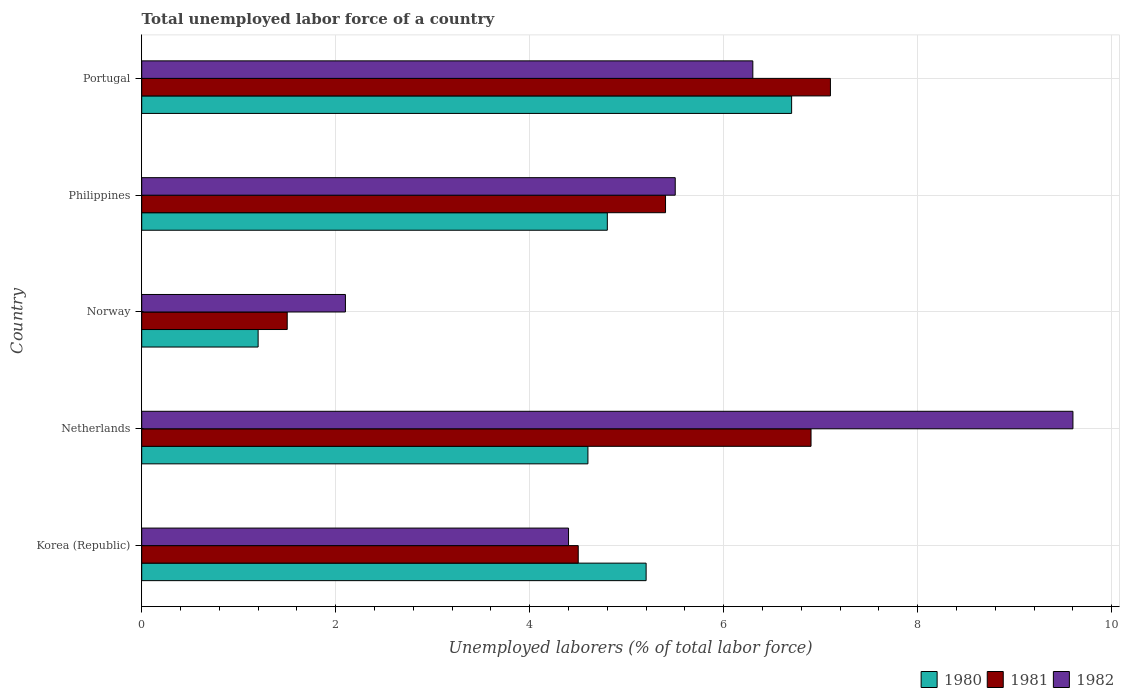How many different coloured bars are there?
Provide a succinct answer. 3. In how many cases, is the number of bars for a given country not equal to the number of legend labels?
Ensure brevity in your answer.  0. Across all countries, what is the maximum total unemployed labor force in 1980?
Offer a very short reply. 6.7. Across all countries, what is the minimum total unemployed labor force in 1981?
Your response must be concise. 1.5. In which country was the total unemployed labor force in 1981 minimum?
Your answer should be compact. Norway. What is the total total unemployed labor force in 1982 in the graph?
Offer a terse response. 27.9. What is the difference between the total unemployed labor force in 1980 in Norway and that in Philippines?
Your response must be concise. -3.6. What is the difference between the total unemployed labor force in 1982 in Norway and the total unemployed labor force in 1980 in Korea (Republic)?
Provide a succinct answer. -3.1. What is the average total unemployed labor force in 1981 per country?
Offer a terse response. 5.08. What is the difference between the total unemployed labor force in 1981 and total unemployed labor force in 1982 in Philippines?
Offer a very short reply. -0.1. What is the ratio of the total unemployed labor force in 1981 in Korea (Republic) to that in Netherlands?
Provide a succinct answer. 0.65. Is the total unemployed labor force in 1982 in Netherlands less than that in Norway?
Your answer should be very brief. No. What is the difference between the highest and the second highest total unemployed labor force in 1981?
Your response must be concise. 0.2. What is the difference between the highest and the lowest total unemployed labor force in 1982?
Ensure brevity in your answer.  7.5. In how many countries, is the total unemployed labor force in 1982 greater than the average total unemployed labor force in 1982 taken over all countries?
Provide a succinct answer. 2. Is it the case that in every country, the sum of the total unemployed labor force in 1980 and total unemployed labor force in 1981 is greater than the total unemployed labor force in 1982?
Make the answer very short. Yes. How many bars are there?
Your response must be concise. 15. Are the values on the major ticks of X-axis written in scientific E-notation?
Make the answer very short. No. Does the graph contain any zero values?
Provide a short and direct response. No. Does the graph contain grids?
Your answer should be very brief. Yes. How many legend labels are there?
Your response must be concise. 3. What is the title of the graph?
Your answer should be compact. Total unemployed labor force of a country. Does "2008" appear as one of the legend labels in the graph?
Your response must be concise. No. What is the label or title of the X-axis?
Your response must be concise. Unemployed laborers (% of total labor force). What is the Unemployed laborers (% of total labor force) in 1980 in Korea (Republic)?
Provide a short and direct response. 5.2. What is the Unemployed laborers (% of total labor force) in 1982 in Korea (Republic)?
Your answer should be compact. 4.4. What is the Unemployed laborers (% of total labor force) in 1980 in Netherlands?
Provide a succinct answer. 4.6. What is the Unemployed laborers (% of total labor force) in 1981 in Netherlands?
Offer a very short reply. 6.9. What is the Unemployed laborers (% of total labor force) in 1982 in Netherlands?
Your answer should be very brief. 9.6. What is the Unemployed laborers (% of total labor force) of 1980 in Norway?
Give a very brief answer. 1.2. What is the Unemployed laborers (% of total labor force) of 1982 in Norway?
Your response must be concise. 2.1. What is the Unemployed laborers (% of total labor force) of 1980 in Philippines?
Ensure brevity in your answer.  4.8. What is the Unemployed laborers (% of total labor force) of 1981 in Philippines?
Give a very brief answer. 5.4. What is the Unemployed laborers (% of total labor force) in 1980 in Portugal?
Your response must be concise. 6.7. What is the Unemployed laborers (% of total labor force) of 1981 in Portugal?
Your answer should be very brief. 7.1. What is the Unemployed laborers (% of total labor force) in 1982 in Portugal?
Ensure brevity in your answer.  6.3. Across all countries, what is the maximum Unemployed laborers (% of total labor force) in 1980?
Your answer should be very brief. 6.7. Across all countries, what is the maximum Unemployed laborers (% of total labor force) of 1981?
Give a very brief answer. 7.1. Across all countries, what is the maximum Unemployed laborers (% of total labor force) of 1982?
Your answer should be compact. 9.6. Across all countries, what is the minimum Unemployed laborers (% of total labor force) of 1980?
Provide a short and direct response. 1.2. Across all countries, what is the minimum Unemployed laborers (% of total labor force) in 1981?
Provide a short and direct response. 1.5. Across all countries, what is the minimum Unemployed laborers (% of total labor force) of 1982?
Give a very brief answer. 2.1. What is the total Unemployed laborers (% of total labor force) of 1981 in the graph?
Give a very brief answer. 25.4. What is the total Unemployed laborers (% of total labor force) in 1982 in the graph?
Offer a very short reply. 27.9. What is the difference between the Unemployed laborers (% of total labor force) of 1980 in Korea (Republic) and that in Philippines?
Keep it short and to the point. 0.4. What is the difference between the Unemployed laborers (% of total labor force) of 1982 in Korea (Republic) and that in Philippines?
Your response must be concise. -1.1. What is the difference between the Unemployed laborers (% of total labor force) of 1982 in Korea (Republic) and that in Portugal?
Keep it short and to the point. -1.9. What is the difference between the Unemployed laborers (% of total labor force) in 1980 in Netherlands and that in Norway?
Offer a terse response. 3.4. What is the difference between the Unemployed laborers (% of total labor force) in 1981 in Netherlands and that in Norway?
Your answer should be very brief. 5.4. What is the difference between the Unemployed laborers (% of total labor force) of 1980 in Netherlands and that in Philippines?
Offer a terse response. -0.2. What is the difference between the Unemployed laborers (% of total labor force) in 1980 in Netherlands and that in Portugal?
Give a very brief answer. -2.1. What is the difference between the Unemployed laborers (% of total labor force) in 1980 in Norway and that in Philippines?
Ensure brevity in your answer.  -3.6. What is the difference between the Unemployed laborers (% of total labor force) of 1982 in Norway and that in Philippines?
Your answer should be compact. -3.4. What is the difference between the Unemployed laborers (% of total labor force) of 1980 in Norway and that in Portugal?
Keep it short and to the point. -5.5. What is the difference between the Unemployed laborers (% of total labor force) in 1981 in Norway and that in Portugal?
Offer a very short reply. -5.6. What is the difference between the Unemployed laborers (% of total labor force) of 1982 in Norway and that in Portugal?
Offer a very short reply. -4.2. What is the difference between the Unemployed laborers (% of total labor force) of 1981 in Philippines and that in Portugal?
Keep it short and to the point. -1.7. What is the difference between the Unemployed laborers (% of total labor force) of 1981 in Korea (Republic) and the Unemployed laborers (% of total labor force) of 1982 in Netherlands?
Offer a very short reply. -5.1. What is the difference between the Unemployed laborers (% of total labor force) of 1980 in Korea (Republic) and the Unemployed laborers (% of total labor force) of 1982 in Philippines?
Your answer should be compact. -0.3. What is the difference between the Unemployed laborers (% of total labor force) in 1981 in Korea (Republic) and the Unemployed laborers (% of total labor force) in 1982 in Philippines?
Your answer should be compact. -1. What is the difference between the Unemployed laborers (% of total labor force) of 1980 in Korea (Republic) and the Unemployed laborers (% of total labor force) of 1981 in Portugal?
Give a very brief answer. -1.9. What is the difference between the Unemployed laborers (% of total labor force) in 1981 in Korea (Republic) and the Unemployed laborers (% of total labor force) in 1982 in Portugal?
Keep it short and to the point. -1.8. What is the difference between the Unemployed laborers (% of total labor force) of 1980 in Netherlands and the Unemployed laborers (% of total labor force) of 1982 in Norway?
Offer a terse response. 2.5. What is the difference between the Unemployed laborers (% of total labor force) of 1980 in Netherlands and the Unemployed laborers (% of total labor force) of 1982 in Philippines?
Your answer should be compact. -0.9. What is the difference between the Unemployed laborers (% of total labor force) in 1980 in Netherlands and the Unemployed laborers (% of total labor force) in 1982 in Portugal?
Offer a terse response. -1.7. What is the difference between the Unemployed laborers (% of total labor force) of 1980 in Norway and the Unemployed laborers (% of total labor force) of 1981 in Philippines?
Offer a very short reply. -4.2. What is the difference between the Unemployed laborers (% of total labor force) of 1980 in Norway and the Unemployed laborers (% of total labor force) of 1982 in Philippines?
Provide a short and direct response. -4.3. What is the difference between the Unemployed laborers (% of total labor force) in 1981 in Norway and the Unemployed laborers (% of total labor force) in 1982 in Philippines?
Give a very brief answer. -4. What is the difference between the Unemployed laborers (% of total labor force) of 1980 in Norway and the Unemployed laborers (% of total labor force) of 1981 in Portugal?
Your answer should be compact. -5.9. What is the difference between the Unemployed laborers (% of total labor force) of 1981 in Norway and the Unemployed laborers (% of total labor force) of 1982 in Portugal?
Give a very brief answer. -4.8. What is the difference between the Unemployed laborers (% of total labor force) in 1980 in Philippines and the Unemployed laborers (% of total labor force) in 1982 in Portugal?
Your response must be concise. -1.5. What is the average Unemployed laborers (% of total labor force) in 1981 per country?
Your answer should be very brief. 5.08. What is the average Unemployed laborers (% of total labor force) in 1982 per country?
Keep it short and to the point. 5.58. What is the difference between the Unemployed laborers (% of total labor force) in 1980 and Unemployed laborers (% of total labor force) in 1982 in Korea (Republic)?
Your response must be concise. 0.8. What is the difference between the Unemployed laborers (% of total labor force) of 1980 and Unemployed laborers (% of total labor force) of 1981 in Netherlands?
Keep it short and to the point. -2.3. What is the difference between the Unemployed laborers (% of total labor force) in 1981 and Unemployed laborers (% of total labor force) in 1982 in Netherlands?
Ensure brevity in your answer.  -2.7. What is the difference between the Unemployed laborers (% of total labor force) of 1980 and Unemployed laborers (% of total labor force) of 1981 in Norway?
Your answer should be very brief. -0.3. What is the difference between the Unemployed laborers (% of total labor force) in 1980 and Unemployed laborers (% of total labor force) in 1982 in Norway?
Your answer should be very brief. -0.9. What is the difference between the Unemployed laborers (% of total labor force) of 1981 and Unemployed laborers (% of total labor force) of 1982 in Norway?
Make the answer very short. -0.6. What is the difference between the Unemployed laborers (% of total labor force) in 1980 and Unemployed laborers (% of total labor force) in 1981 in Philippines?
Make the answer very short. -0.6. What is the difference between the Unemployed laborers (% of total labor force) in 1980 and Unemployed laborers (% of total labor force) in 1982 in Philippines?
Provide a short and direct response. -0.7. What is the difference between the Unemployed laborers (% of total labor force) of 1981 and Unemployed laborers (% of total labor force) of 1982 in Philippines?
Your response must be concise. -0.1. What is the difference between the Unemployed laborers (% of total labor force) of 1981 and Unemployed laborers (% of total labor force) of 1982 in Portugal?
Your answer should be very brief. 0.8. What is the ratio of the Unemployed laborers (% of total labor force) of 1980 in Korea (Republic) to that in Netherlands?
Offer a terse response. 1.13. What is the ratio of the Unemployed laborers (% of total labor force) of 1981 in Korea (Republic) to that in Netherlands?
Your answer should be compact. 0.65. What is the ratio of the Unemployed laborers (% of total labor force) in 1982 in Korea (Republic) to that in Netherlands?
Your response must be concise. 0.46. What is the ratio of the Unemployed laborers (% of total labor force) in 1980 in Korea (Republic) to that in Norway?
Your answer should be compact. 4.33. What is the ratio of the Unemployed laborers (% of total labor force) of 1982 in Korea (Republic) to that in Norway?
Give a very brief answer. 2.1. What is the ratio of the Unemployed laborers (% of total labor force) of 1980 in Korea (Republic) to that in Philippines?
Your answer should be very brief. 1.08. What is the ratio of the Unemployed laborers (% of total labor force) in 1982 in Korea (Republic) to that in Philippines?
Your answer should be very brief. 0.8. What is the ratio of the Unemployed laborers (% of total labor force) in 1980 in Korea (Republic) to that in Portugal?
Keep it short and to the point. 0.78. What is the ratio of the Unemployed laborers (% of total labor force) of 1981 in Korea (Republic) to that in Portugal?
Your answer should be very brief. 0.63. What is the ratio of the Unemployed laborers (% of total labor force) of 1982 in Korea (Republic) to that in Portugal?
Your answer should be compact. 0.7. What is the ratio of the Unemployed laborers (% of total labor force) in 1980 in Netherlands to that in Norway?
Offer a terse response. 3.83. What is the ratio of the Unemployed laborers (% of total labor force) in 1982 in Netherlands to that in Norway?
Provide a short and direct response. 4.57. What is the ratio of the Unemployed laborers (% of total labor force) in 1981 in Netherlands to that in Philippines?
Offer a very short reply. 1.28. What is the ratio of the Unemployed laborers (% of total labor force) of 1982 in Netherlands to that in Philippines?
Your answer should be compact. 1.75. What is the ratio of the Unemployed laborers (% of total labor force) of 1980 in Netherlands to that in Portugal?
Your answer should be compact. 0.69. What is the ratio of the Unemployed laborers (% of total labor force) in 1981 in Netherlands to that in Portugal?
Your response must be concise. 0.97. What is the ratio of the Unemployed laborers (% of total labor force) of 1982 in Netherlands to that in Portugal?
Ensure brevity in your answer.  1.52. What is the ratio of the Unemployed laborers (% of total labor force) of 1980 in Norway to that in Philippines?
Ensure brevity in your answer.  0.25. What is the ratio of the Unemployed laborers (% of total labor force) in 1981 in Norway to that in Philippines?
Ensure brevity in your answer.  0.28. What is the ratio of the Unemployed laborers (% of total labor force) in 1982 in Norway to that in Philippines?
Provide a succinct answer. 0.38. What is the ratio of the Unemployed laborers (% of total labor force) of 1980 in Norway to that in Portugal?
Your answer should be compact. 0.18. What is the ratio of the Unemployed laborers (% of total labor force) of 1981 in Norway to that in Portugal?
Your answer should be very brief. 0.21. What is the ratio of the Unemployed laborers (% of total labor force) of 1982 in Norway to that in Portugal?
Offer a very short reply. 0.33. What is the ratio of the Unemployed laborers (% of total labor force) in 1980 in Philippines to that in Portugal?
Provide a short and direct response. 0.72. What is the ratio of the Unemployed laborers (% of total labor force) of 1981 in Philippines to that in Portugal?
Your answer should be compact. 0.76. What is the ratio of the Unemployed laborers (% of total labor force) of 1982 in Philippines to that in Portugal?
Offer a very short reply. 0.87. What is the difference between the highest and the second highest Unemployed laborers (% of total labor force) of 1980?
Keep it short and to the point. 1.5. What is the difference between the highest and the lowest Unemployed laborers (% of total labor force) in 1981?
Offer a very short reply. 5.6. What is the difference between the highest and the lowest Unemployed laborers (% of total labor force) of 1982?
Offer a very short reply. 7.5. 